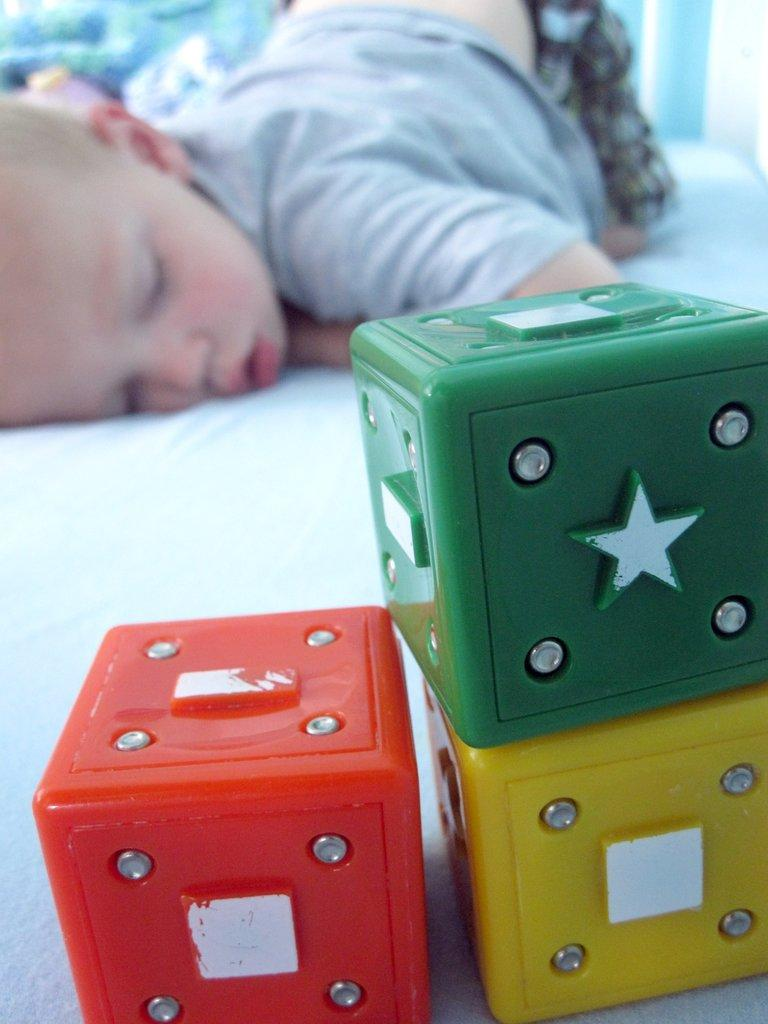What is the main subject of the image? The main subject of the image is a person sleeping. What is the person sleeping on? The person is sleeping on a white cloth. What other objects can be seen in the image? There are cubes in the image. Where is the object located in the image? There is an object in the top left corner of the image. What nation is the stranger from in the image? There is no stranger present in the image, and therefore no nation can be associated with them. 